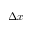<formula> <loc_0><loc_0><loc_500><loc_500>\Delta x</formula> 